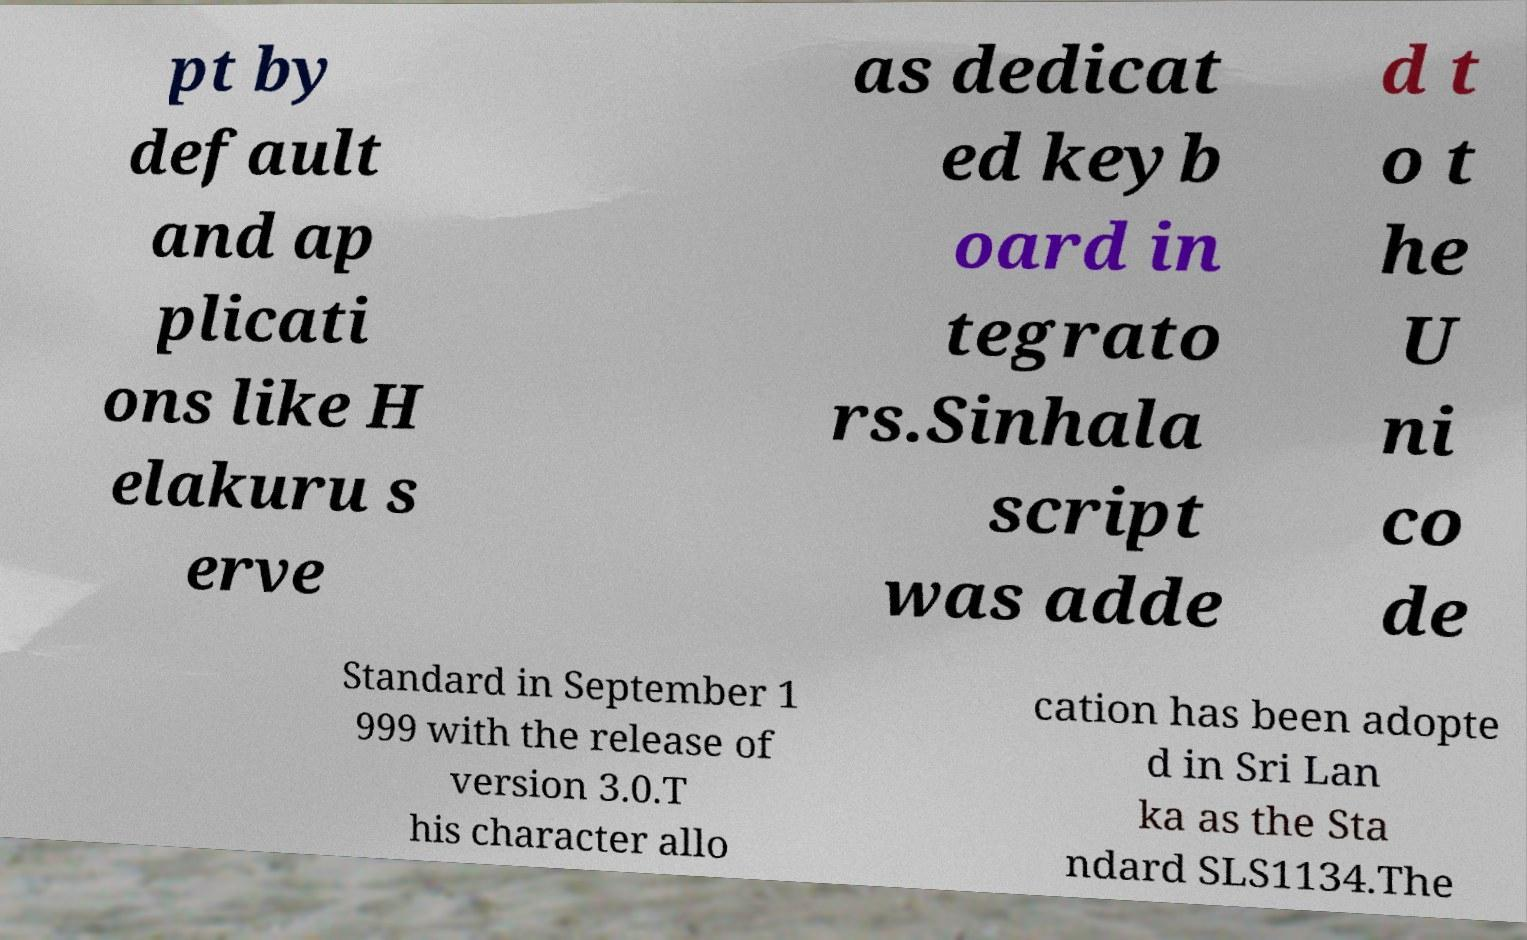What messages or text are displayed in this image? I need them in a readable, typed format. pt by default and ap plicati ons like H elakuru s erve as dedicat ed keyb oard in tegrato rs.Sinhala script was adde d t o t he U ni co de Standard in September 1 999 with the release of version 3.0.T his character allo cation has been adopte d in Sri Lan ka as the Sta ndard SLS1134.The 